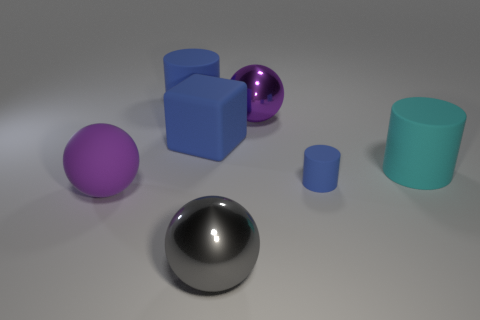Add 2 blue rubber cubes. How many objects exist? 9 Subtract all spheres. How many objects are left? 4 Add 3 large gray metallic balls. How many large gray metallic balls are left? 4 Add 3 big purple shiny balls. How many big purple shiny balls exist? 4 Subtract 0 red cylinders. How many objects are left? 7 Subtract all cyan matte things. Subtract all big matte balls. How many objects are left? 5 